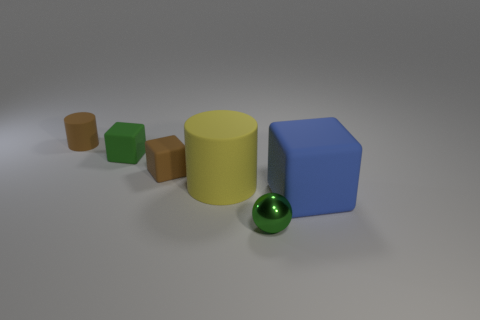Subtract all small blocks. How many blocks are left? 1 Add 2 gray rubber blocks. How many objects exist? 8 Subtract 1 balls. How many balls are left? 0 Subtract all blue cubes. How many cubes are left? 2 Subtract all cylinders. How many objects are left? 4 Subtract 1 brown cylinders. How many objects are left? 5 Subtract all gray cylinders. Subtract all purple spheres. How many cylinders are left? 2 Subtract all brown cubes. How many brown cylinders are left? 1 Subtract all small green rubber things. Subtract all red matte objects. How many objects are left? 5 Add 5 tiny brown rubber cubes. How many tiny brown rubber cubes are left? 6 